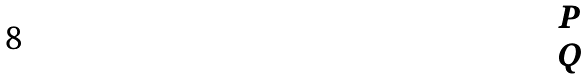<formula> <loc_0><loc_0><loc_500><loc_500>\begin{matrix} P \\ Q \end{matrix}</formula> 